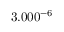<formula> <loc_0><loc_0><loc_500><loc_500>3 . 0 0 \ t i m e 1 0 ^ { - 6 }</formula> 